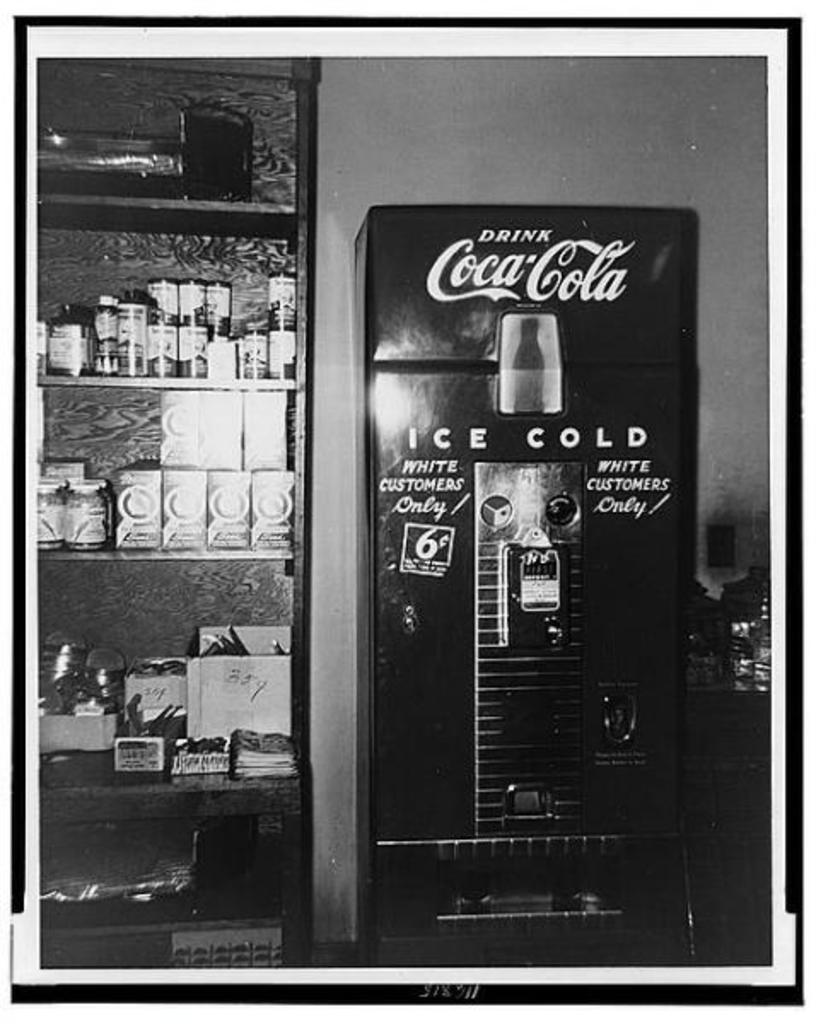<image>
Summarize the visual content of the image. An old coke vending machine next to a pantry. 